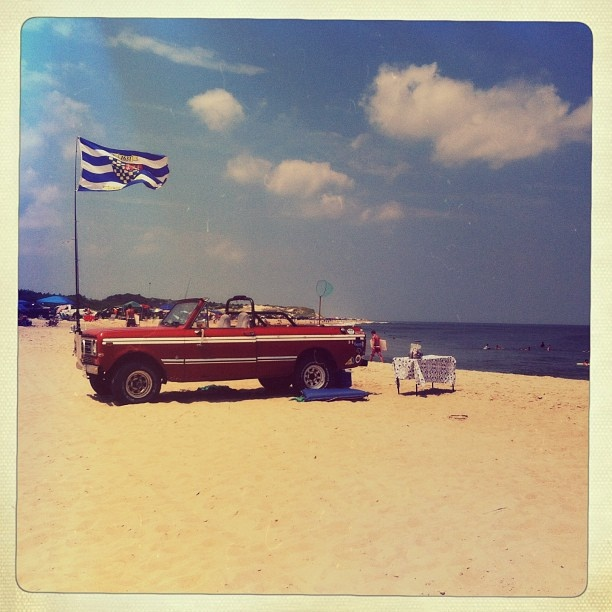Describe the objects in this image and their specific colors. I can see truck in beige, maroon, black, and brown tones, car in beige, maroon, black, and brown tones, dining table in beige, gray, tan, brown, and darkgray tones, surfboard in beige, navy, and purple tones, and car in beige, black, gray, tan, and darkgray tones in this image. 